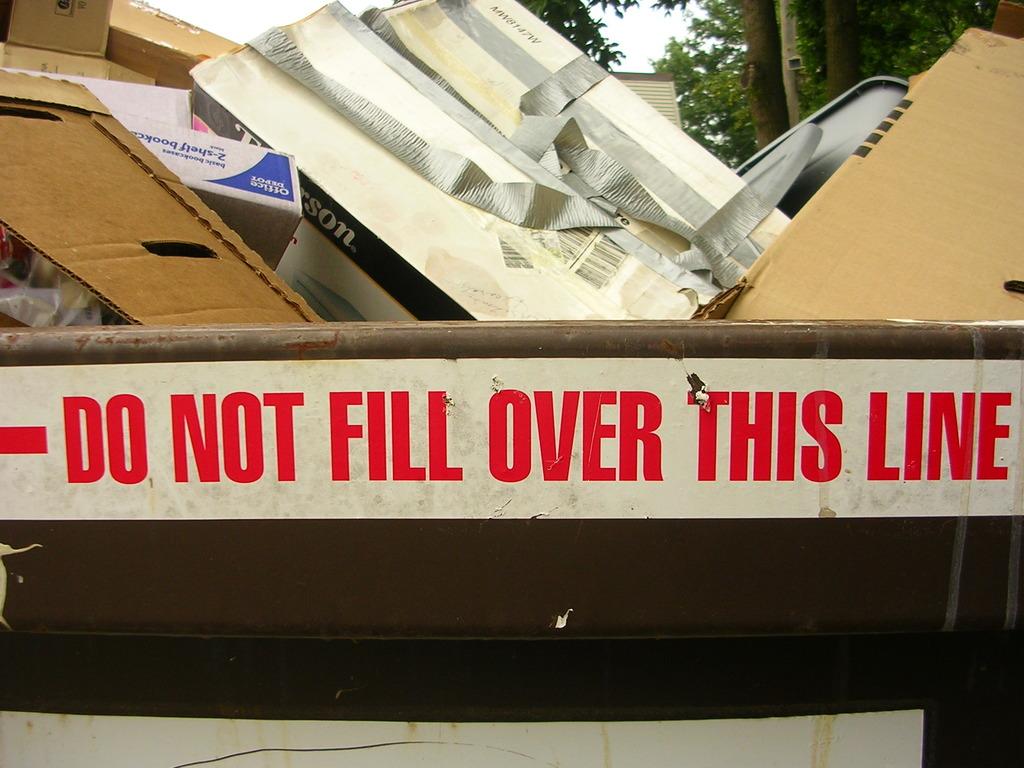What does this sticker say to not do?
Make the answer very short. Fill over this line. What is written in red?
Offer a very short reply. Do not fill over this line. 